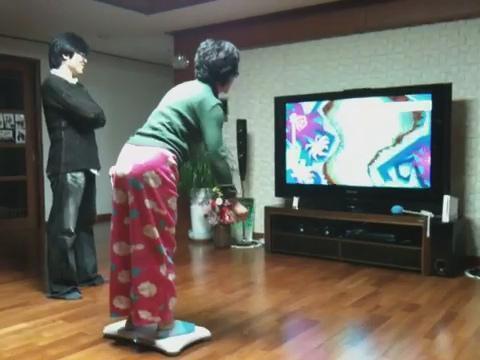How many people are in the picture?
Give a very brief answer. 2. 